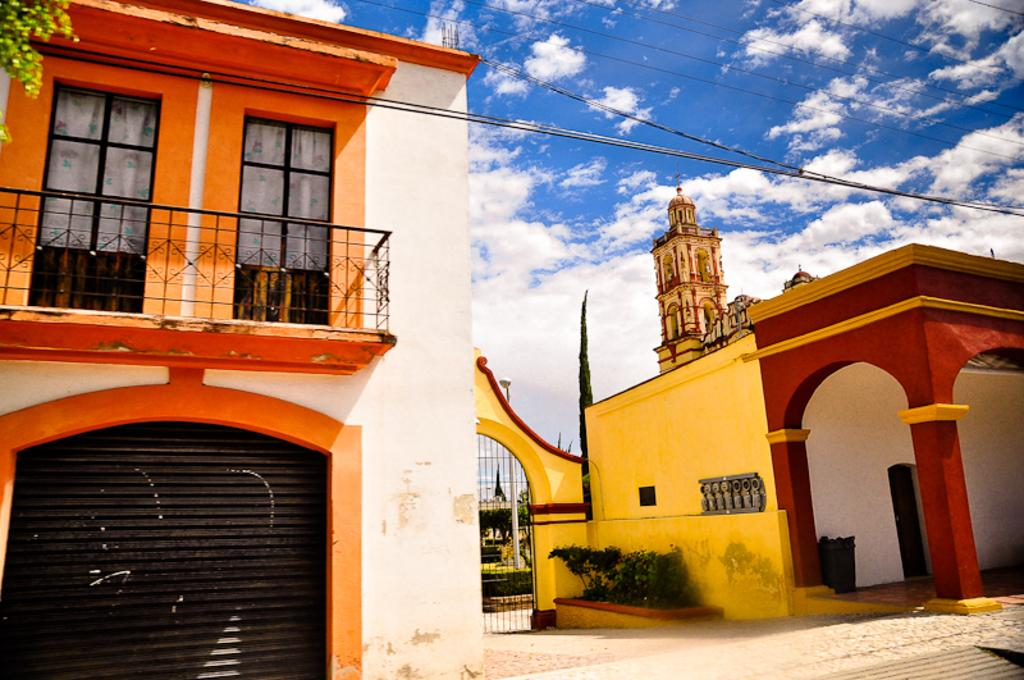What type of structures can be seen in the image? There are buildings in the image. What other elements are present in the image besides buildings? There are plants, cables, trees, and clouds visible in the image. Can you describe the vegetation in the image? There are plants and trees present in the image. What is visible in the sky in the image? Clouds are present in the image. What type of quilt is being used to cover the trees in the image? There is no quilt present in the image; it features buildings, plants, cables, trees, and clouds. What kind of fowl can be seen flying among the clouds in the image? There are no birds or fowl visible in the image; only clouds are present in the sky. 